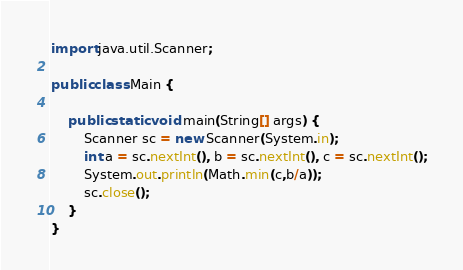Convert code to text. <code><loc_0><loc_0><loc_500><loc_500><_Java_>import java.util.Scanner;

public class Main {

	public static void main(String[] args) {
		Scanner sc = new Scanner(System.in);
		int a = sc.nextInt(), b = sc.nextInt(), c = sc.nextInt();
		System.out.println(Math.min(c,b/a));
		sc.close();
	}
}</code> 